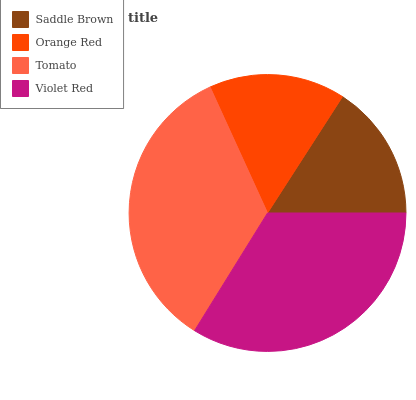Is Saddle Brown the minimum?
Answer yes or no. Yes. Is Tomato the maximum?
Answer yes or no. Yes. Is Orange Red the minimum?
Answer yes or no. No. Is Orange Red the maximum?
Answer yes or no. No. Is Orange Red greater than Saddle Brown?
Answer yes or no. Yes. Is Saddle Brown less than Orange Red?
Answer yes or no. Yes. Is Saddle Brown greater than Orange Red?
Answer yes or no. No. Is Orange Red less than Saddle Brown?
Answer yes or no. No. Is Violet Red the high median?
Answer yes or no. Yes. Is Orange Red the low median?
Answer yes or no. Yes. Is Saddle Brown the high median?
Answer yes or no. No. Is Saddle Brown the low median?
Answer yes or no. No. 